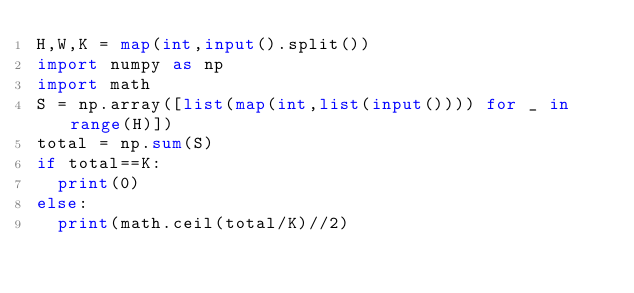Convert code to text. <code><loc_0><loc_0><loc_500><loc_500><_Python_>H,W,K = map(int,input().split())
import numpy as np
import math
S = np.array([list(map(int,list(input()))) for _ in range(H)])
total = np.sum(S)
if total==K:
  print(0)
else:
  print(math.ceil(total/K)//2)</code> 